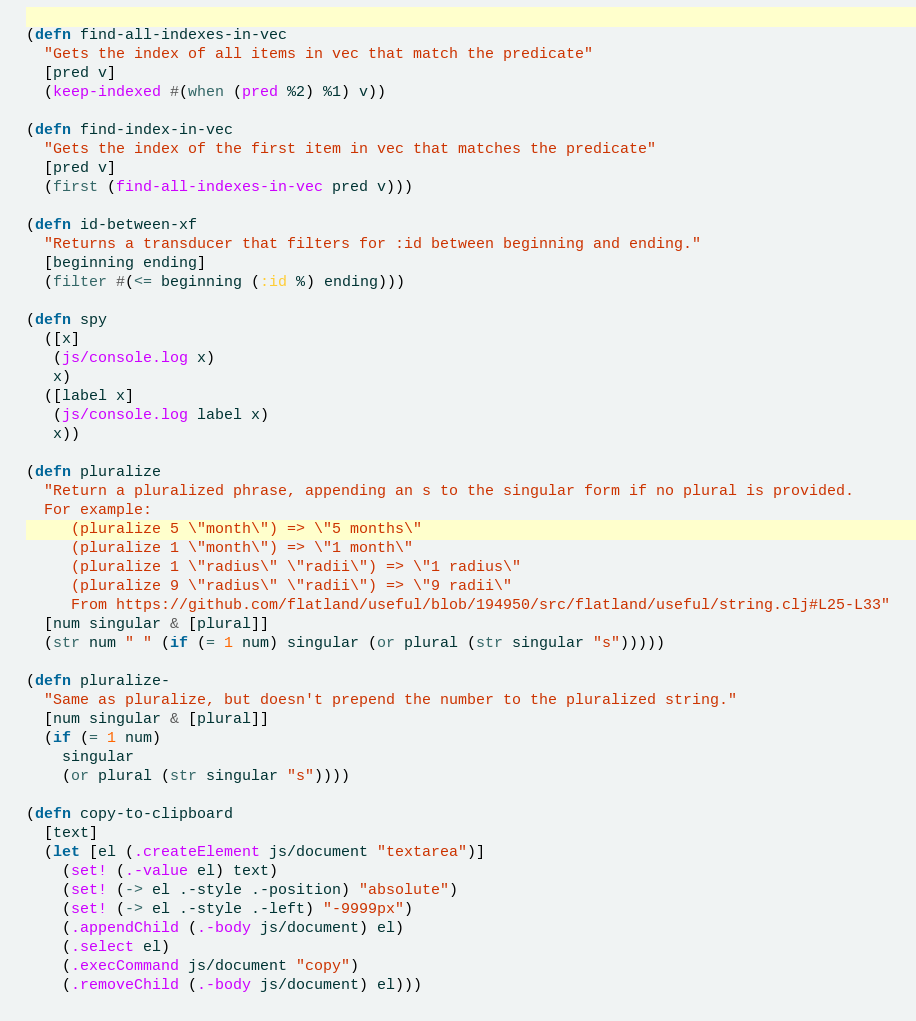Convert code to text. <code><loc_0><loc_0><loc_500><loc_500><_Clojure_>
(defn find-all-indexes-in-vec
  "Gets the index of all items in vec that match the predicate"
  [pred v]
  (keep-indexed #(when (pred %2) %1) v))

(defn find-index-in-vec
  "Gets the index of the first item in vec that matches the predicate"
  [pred v]
  (first (find-all-indexes-in-vec pred v)))

(defn id-between-xf
  "Returns a transducer that filters for :id between beginning and ending."
  [beginning ending]
  (filter #(<= beginning (:id %) ending)))

(defn spy
  ([x]
   (js/console.log x)
   x)
  ([label x]
   (js/console.log label x)
   x))

(defn pluralize
  "Return a pluralized phrase, appending an s to the singular form if no plural is provided.
  For example:
     (pluralize 5 \"month\") => \"5 months\"
     (pluralize 1 \"month\") => \"1 month\"
     (pluralize 1 \"radius\" \"radii\") => \"1 radius\"
     (pluralize 9 \"radius\" \"radii\") => \"9 radii\"
     From https://github.com/flatland/useful/blob/194950/src/flatland/useful/string.clj#L25-L33"
  [num singular & [plural]]
  (str num " " (if (= 1 num) singular (or plural (str singular "s")))))

(defn pluralize-
  "Same as pluralize, but doesn't prepend the number to the pluralized string."
  [num singular & [plural]]
  (if (= 1 num)
    singular
    (or plural (str singular "s"))))

(defn copy-to-clipboard
  [text]
  (let [el (.createElement js/document "textarea")]
    (set! (.-value el) text)
    (set! (-> el .-style .-position) "absolute")
    (set! (-> el .-style .-left) "-9999px")
    (.appendChild (.-body js/document) el)
    (.select el)
    (.execCommand js/document "copy")
    (.removeChild (.-body js/document) el)))
</code> 